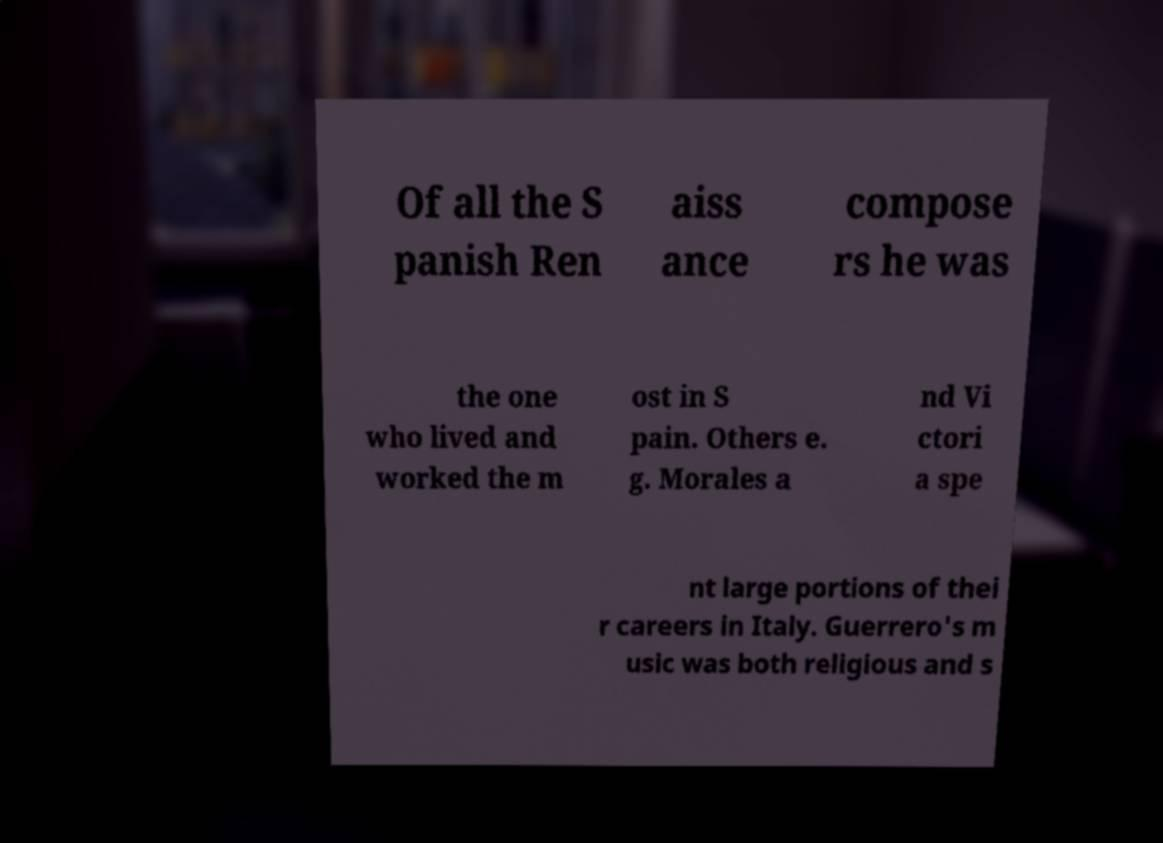Can you accurately transcribe the text from the provided image for me? Of all the S panish Ren aiss ance compose rs he was the one who lived and worked the m ost in S pain. Others e. g. Morales a nd Vi ctori a spe nt large portions of thei r careers in Italy. Guerrero's m usic was both religious and s 